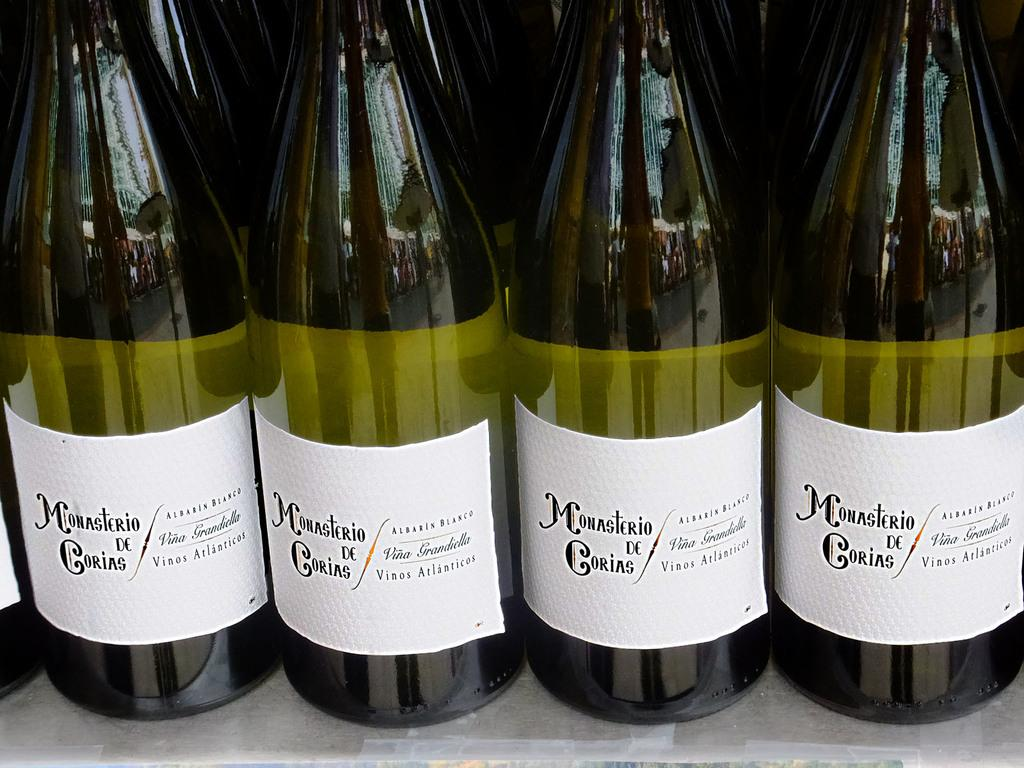<image>
Share a concise interpretation of the image provided. the word Monasterio is on a bottle of wine 